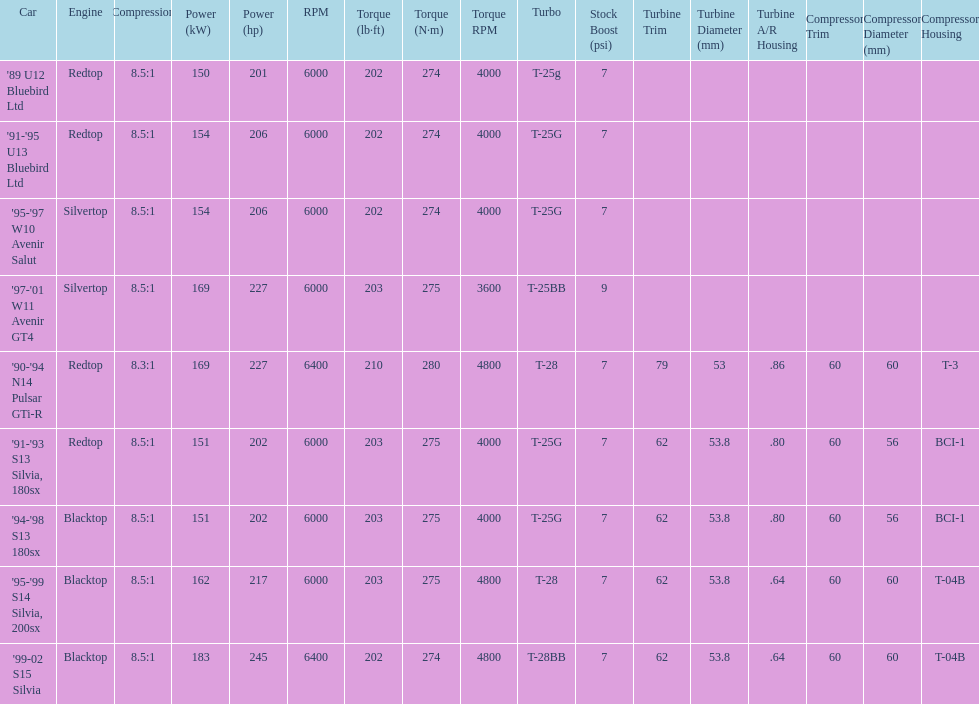What is his/her compression for the 90-94 n14 pulsar gti-r? 8.3:1. 